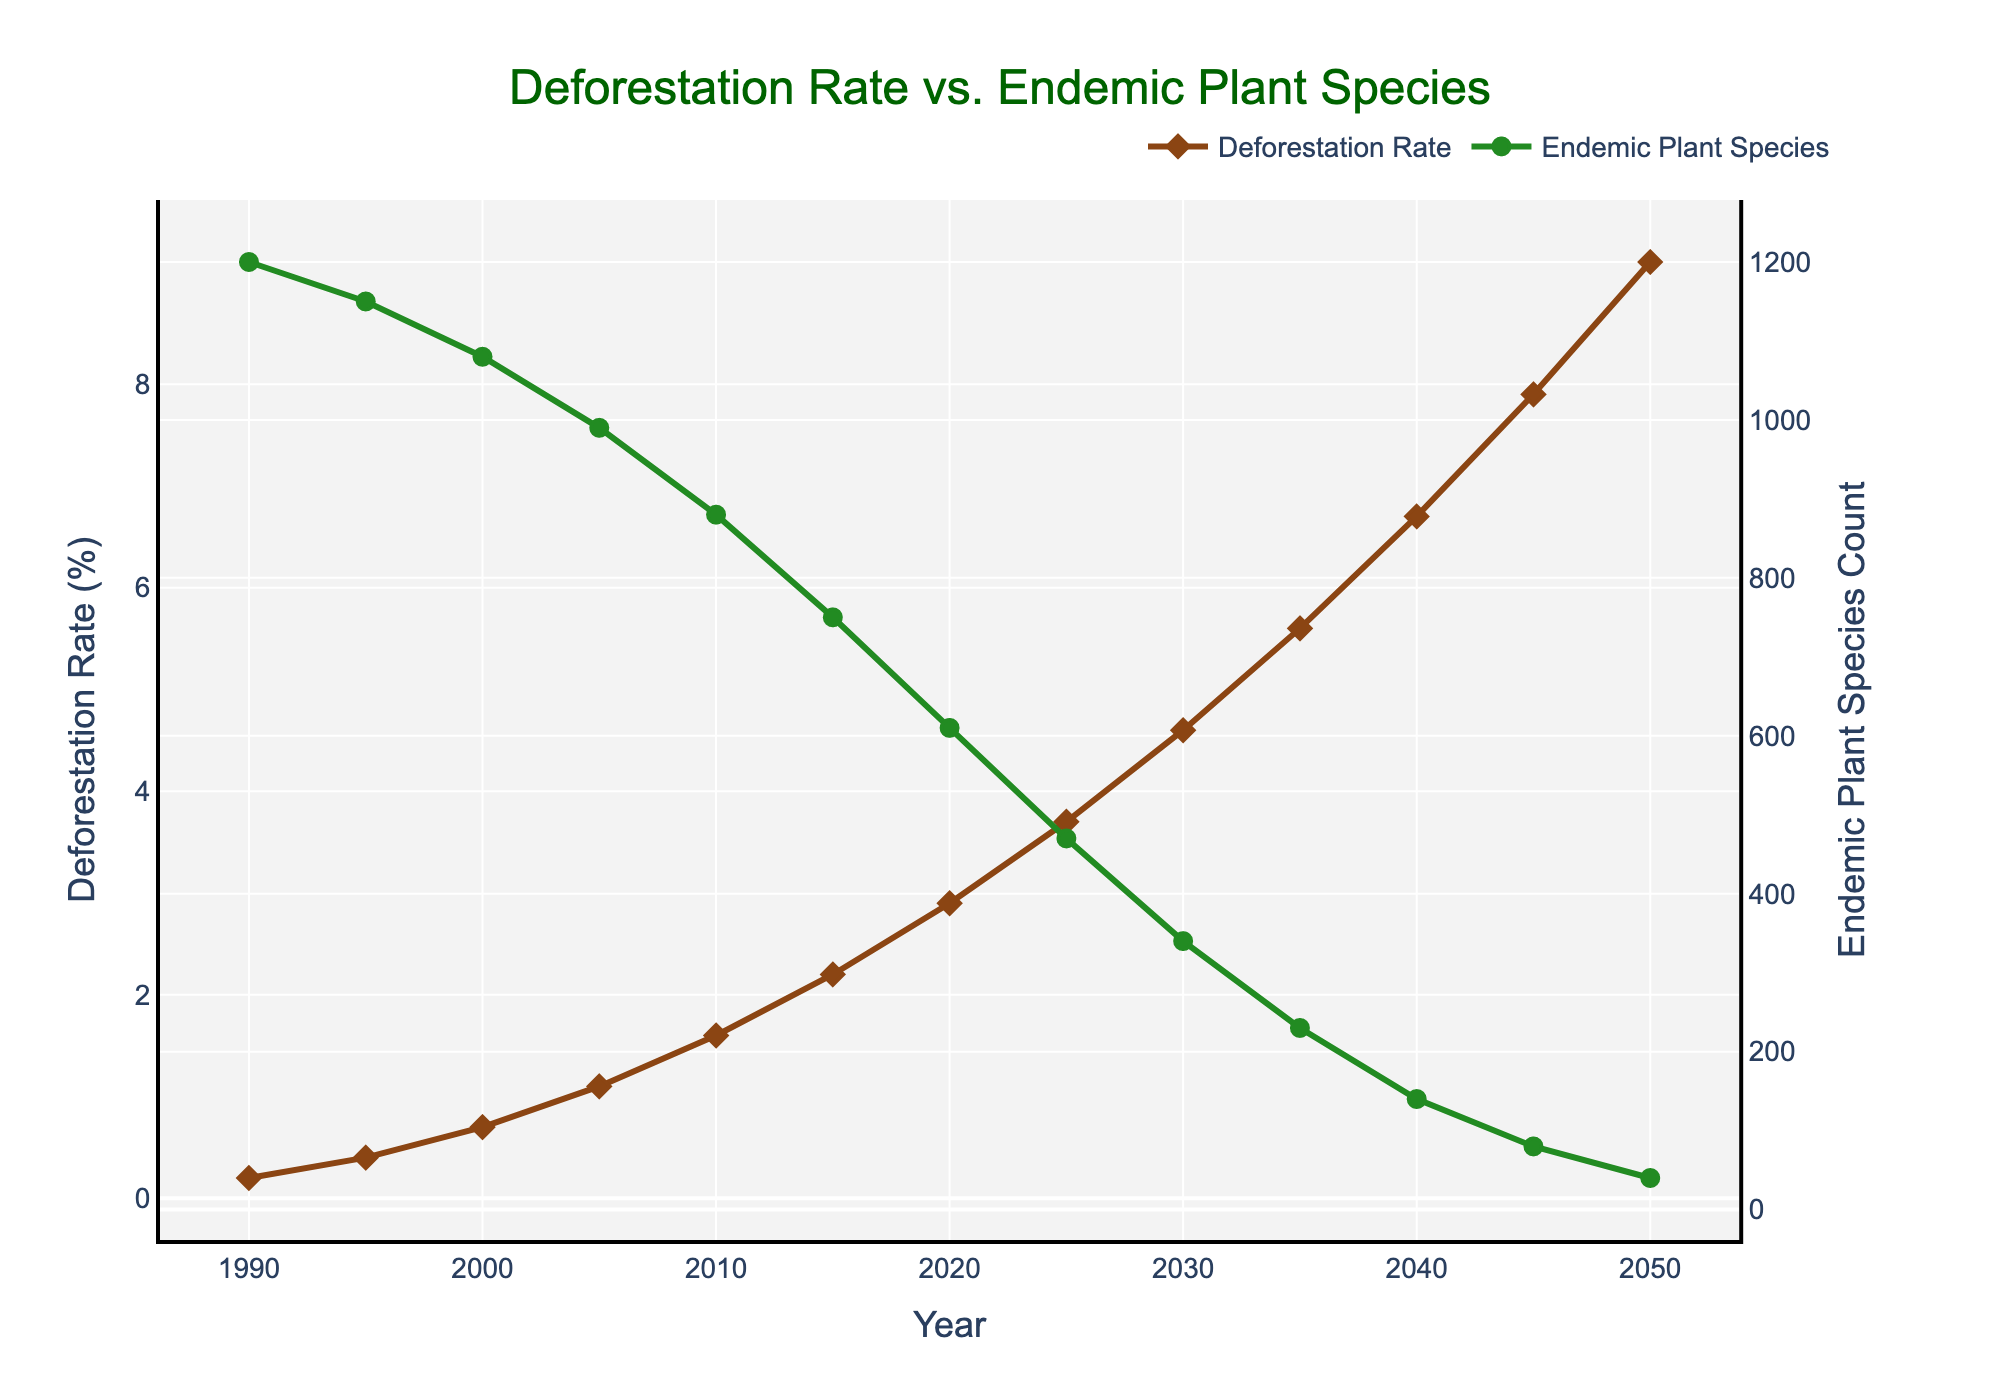What is the deforestation rate in 2040? Looking at the graph, locate the point corresponding to the year 2040 on the x-axis. From that point, move vertically until you reach the deforestation rate line. The y-axis on the left shows that the deforestation rate is 6.7%.
Answer: 6.7% How many endemic plant species are there in 2025? Locate the year 2025 on the x-axis, then find the point on the endemic plant species line directly above it. The y-axis on the right indicates that there are 470 endemic plant species in 2025.
Answer: 470 What's the deforestation rate increase from 2000 to 2050? Find the deforestation rate for the year 2000 (0.7%) and for 2050 (9.2%), then subtract the 2000 value from the 2050 value to get the increase. 9.2% - 0.7% = 8.5%.
Answer: 8.5% Which year shows a steep decline in the number of endemic plant species? Look at the slope of the endemic plant species line. The steepest decline is between 2015 and 2020, indicated by the sharpest drop.
Answer: Between 2015 and 2020 How does the deforestation rate in 2015 compare to 1995? Compare the y-values of the deforestation rate line at the points for 2015 (2.2%) and 1995 (0.4%). 2.2% is significantly greater than 0.4%.
Answer: 2015 is higher In which year were there approximately 750 endemic plant species? Locate 750 on the endemic plant species y-axis on the right. Then, trace horizontally to the intersection with the endemic plant species line and follow down to the x-axis to find the year 2015.
Answer: 2015 What is the average deforestation rate between 1990 and 2000? Sum the deforestation rates for the years 1990 (0.2%), 1995 (0.4%), and 2000 (0.7%), then divide by 3. (0.2 + 0.4 + 0.7) / 3 = 0.4333%.
Answer: 0.4333% By what percentage has the count of endemic plants decreased from 1990 to 2050? Find the plant count for 1990 (1200) and 2050 (40). Calculate the decrease: 1200 - 40 = 1160. Then, take the decrease divided by the 1990 count and multiply by 100 to get the percentage: (1160 / 1200) * 100 = 96.67%.
Answer: 96.67% What is the trend for deforestation rates and endemic plant species from 1990 to 2050? There is a clear upward trend in deforestation rates, indicating a continuous increase. Conversely, the trend for endemic plant species is sharply downward, indicating a rapid decline.
Answer: Increasing deforestation, decreasing plant species In which range of years did the deforestation rate exceed 5%? Identify the region on the graph where the deforestation rate line crosses above the 5% mark on the y-axis. This happens after 2035.
Answer: After 2035 